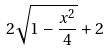Convert formula to latex. <formula><loc_0><loc_0><loc_500><loc_500>2 \sqrt { 1 - \frac { x ^ { 2 } } { 4 } } + 2</formula> 